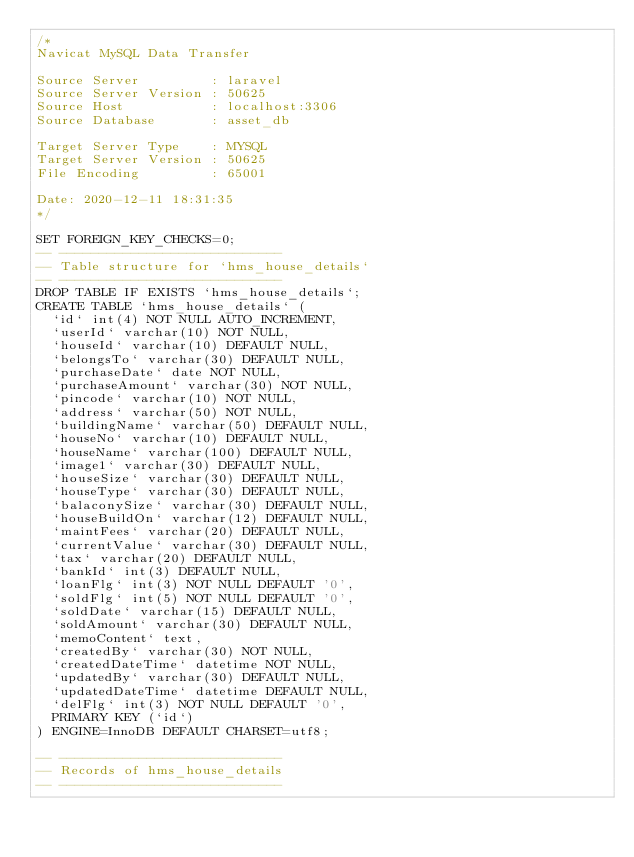<code> <loc_0><loc_0><loc_500><loc_500><_SQL_>/*
Navicat MySQL Data Transfer

Source Server         : laravel
Source Server Version : 50625
Source Host           : localhost:3306
Source Database       : asset_db

Target Server Type    : MYSQL
Target Server Version : 50625
File Encoding         : 65001

Date: 2020-12-11 18:31:35
*/

SET FOREIGN_KEY_CHECKS=0;
-- ----------------------------
-- Table structure for `hms_house_details`
-- ----------------------------
DROP TABLE IF EXISTS `hms_house_details`;
CREATE TABLE `hms_house_details` (
  `id` int(4) NOT NULL AUTO_INCREMENT,
  `userId` varchar(10) NOT NULL,
  `houseId` varchar(10) DEFAULT NULL,
  `belongsTo` varchar(30) DEFAULT NULL,
  `purchaseDate` date NOT NULL,
  `purchaseAmount` varchar(30) NOT NULL,
  `pincode` varchar(10) NOT NULL,
  `address` varchar(50) NOT NULL,
  `buildingName` varchar(50) DEFAULT NULL,
  `houseNo` varchar(10) DEFAULT NULL,
  `houseName` varchar(100) DEFAULT NULL,
  `image1` varchar(30) DEFAULT NULL,
  `houseSize` varchar(30) DEFAULT NULL,
  `houseType` varchar(30) DEFAULT NULL,
  `balaconySize` varchar(30) DEFAULT NULL,
  `houseBuildOn` varchar(12) DEFAULT NULL,
  `maintFees` varchar(20) DEFAULT NULL,
  `currentValue` varchar(30) DEFAULT NULL,
  `tax` varchar(20) DEFAULT NULL,
  `bankId` int(3) DEFAULT NULL,
  `loanFlg` int(3) NOT NULL DEFAULT '0',
  `soldFlg` int(5) NOT NULL DEFAULT '0',
  `soldDate` varchar(15) DEFAULT NULL,
  `soldAmount` varchar(30) DEFAULT NULL,
  `memoContent` text,
  `createdBy` varchar(30) NOT NULL,
  `createdDateTime` datetime NOT NULL,
  `updatedBy` varchar(30) DEFAULT NULL,
  `updatedDateTime` datetime DEFAULT NULL,
  `delFlg` int(3) NOT NULL DEFAULT '0',
  PRIMARY KEY (`id`)
) ENGINE=InnoDB DEFAULT CHARSET=utf8;

-- ----------------------------
-- Records of hms_house_details
-- ----------------------------
</code> 